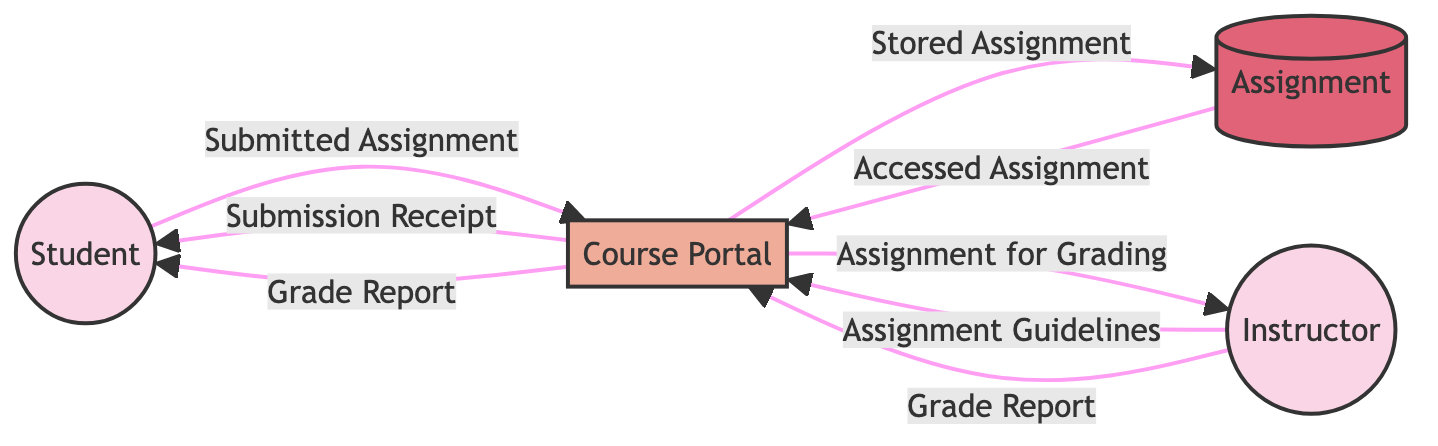What is the external entity that submits the assignment? The diagram identifies "Student" as an external entity who is responsible for submitting the assignment.
Answer: Student How many data flows are there in the diagram? The diagram includes a total of eight data flows that connect different entities and processes, indicating the movement of information.
Answer: 8 Which entity provides the assignment guidelines? According to the diagram, "Instructor" is the entity that sends the assignment guidelines to the course portal.
Answer: Instructor What is the data store used for in the workflow? The "Assignment" serves as the data store where submitted assignments are kept until accessed for grading.
Answer: Assignment What does the course portal send to the student upon successful submission? The course portal sends a "Submission Receipt" to the student to acknowledge their submission.
Answer: Submission Receipt Which two entities are involved in the grading process? The "Instructor" and the "Course Portal" are the two entities involved in the grading process, where the instructor grades and sends feedback.
Answer: Instructor and Course Portal What data flow originates from the assignment data store? The "Accessed Assignment" data flow originates from the assignment data store and returns to the course portal.
Answer: Accessed Assignment What type of diagram is being represented in this diagram? The diagram represents a "Data Flow Diagram," which shows the flow of information between entities and processes in the assignment submission workflow.
Answer: Data Flow Diagram 